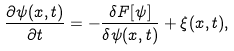<formula> <loc_0><loc_0><loc_500><loc_500>\frac { \partial \psi ( { x } , t ) } { \partial t } = - \frac { \delta F [ \psi ] } { \delta \psi ( { x } , t ) } + \xi ( { x } , t ) ,</formula> 